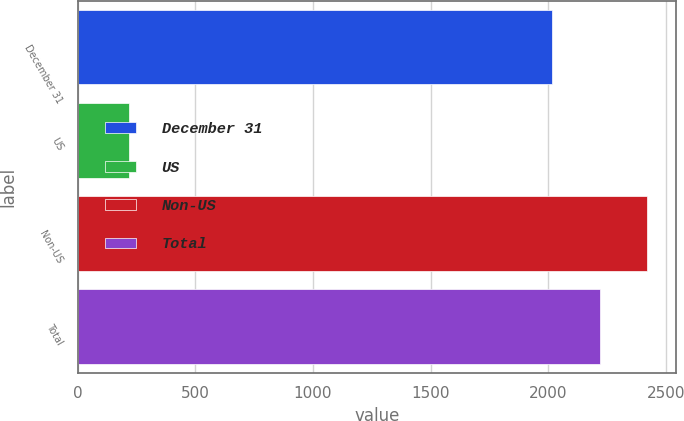<chart> <loc_0><loc_0><loc_500><loc_500><bar_chart><fcel>December 31<fcel>US<fcel>Non-US<fcel>Total<nl><fcel>2018<fcel>218<fcel>2421.6<fcel>2219.8<nl></chart> 